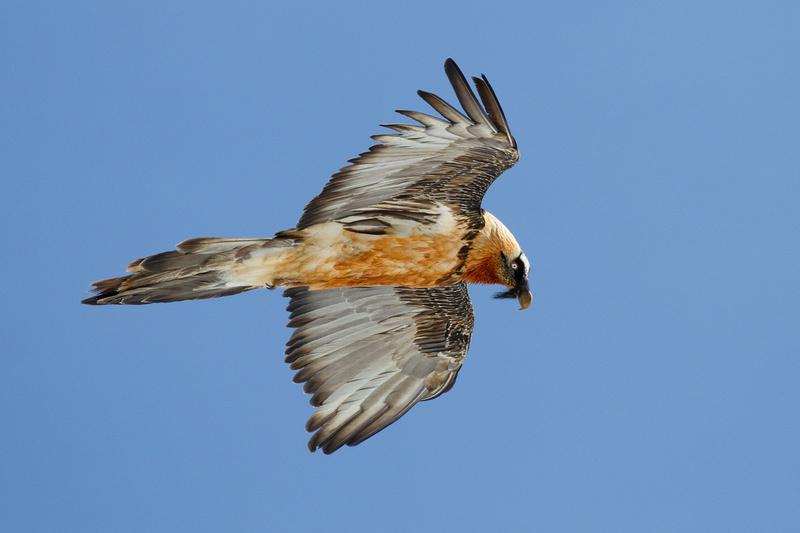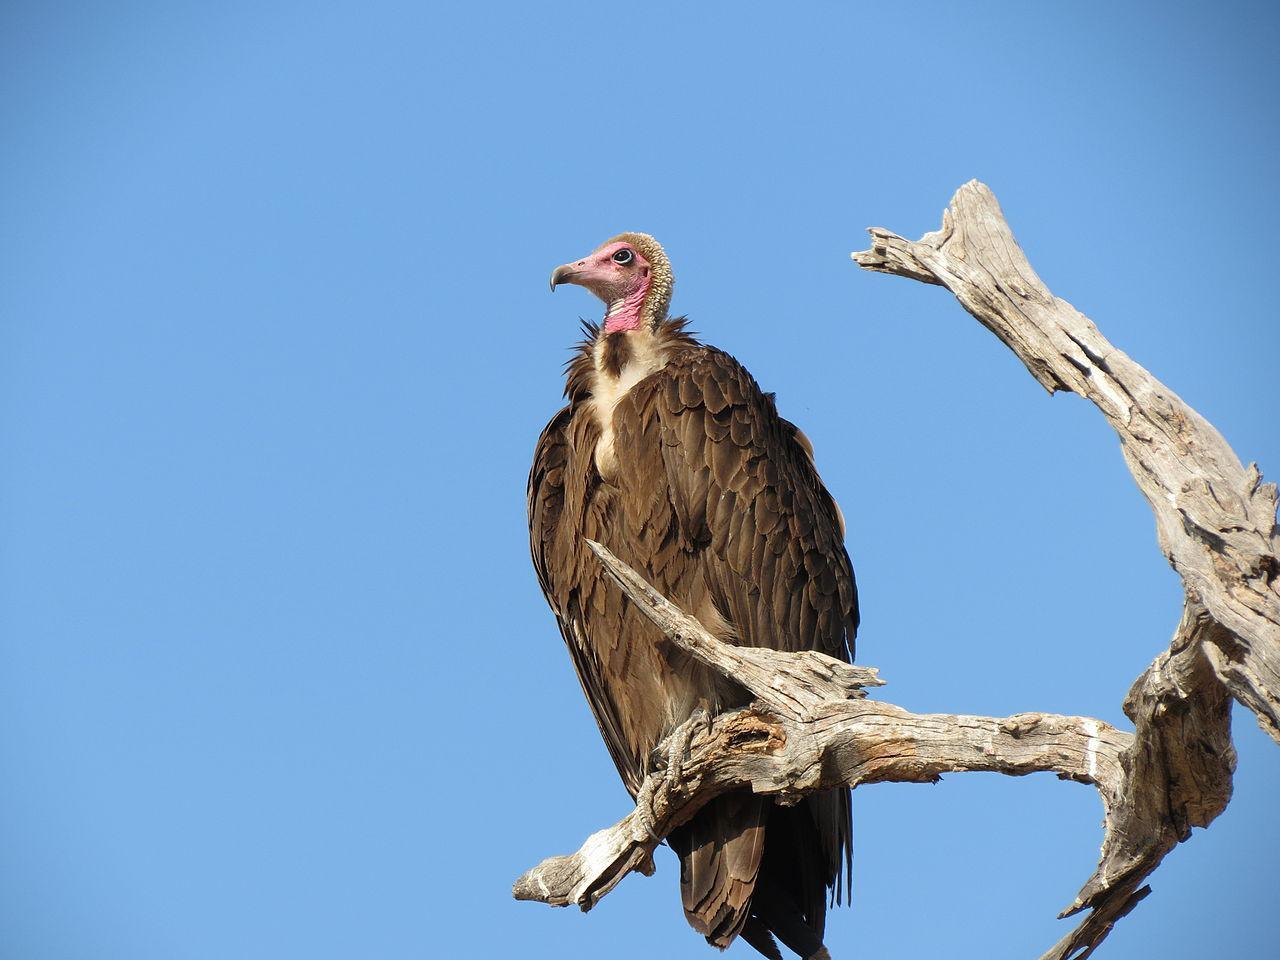The first image is the image on the left, the second image is the image on the right. Given the left and right images, does the statement "In the left image, a bird is flying." hold true? Answer yes or no. Yes. 